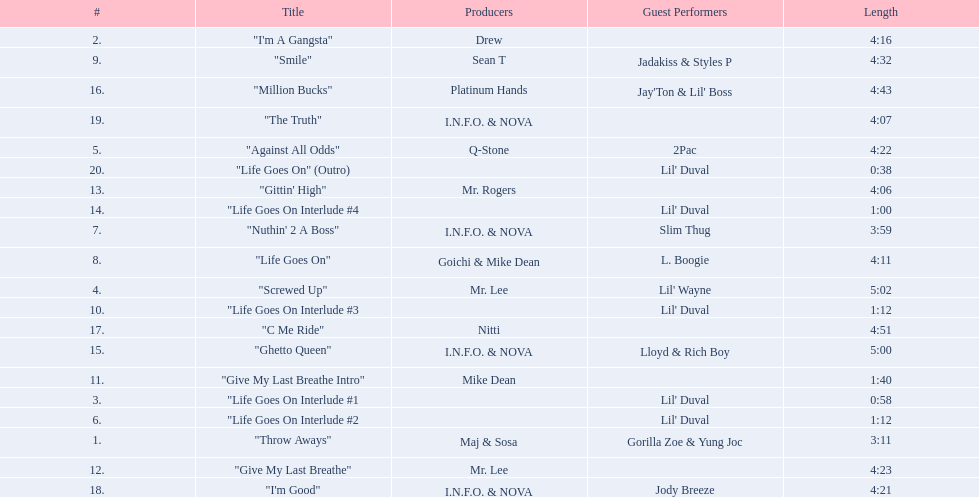How long is the longest track on the album? 5:02. 